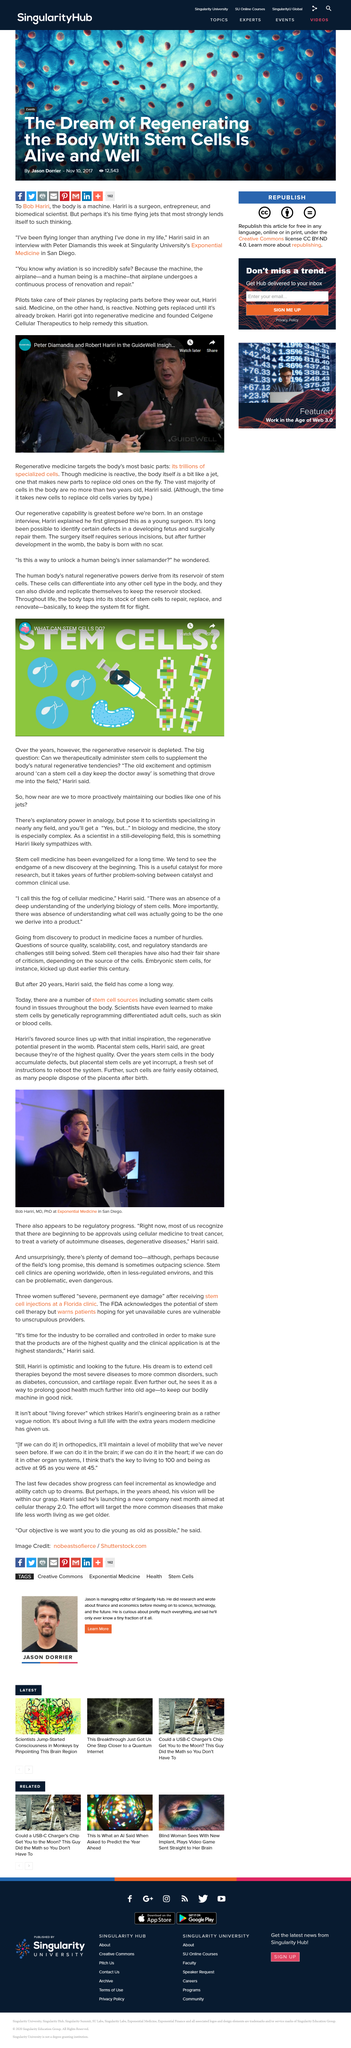Highlight a few significant elements in this photo. Placental stem cells in the womb exhibit regenerative potential, as they have the ability to differentiate into various cell types and repair damaged tissues. Stem cells have the ability to repair, replace, and renovate damaged or diseased cells and tissues. The above picture was taken in San Diego. The names of the individuals featured in the video are Peter Diamandis and Robert Hariri. Yes, stem cells have the capability to divide and replicate themselves. 